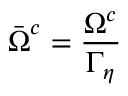<formula> <loc_0><loc_0><loc_500><loc_500>\bar { \Omega } ^ { c } = \frac { \Omega ^ { c } } { \Gamma _ { \eta } }</formula> 